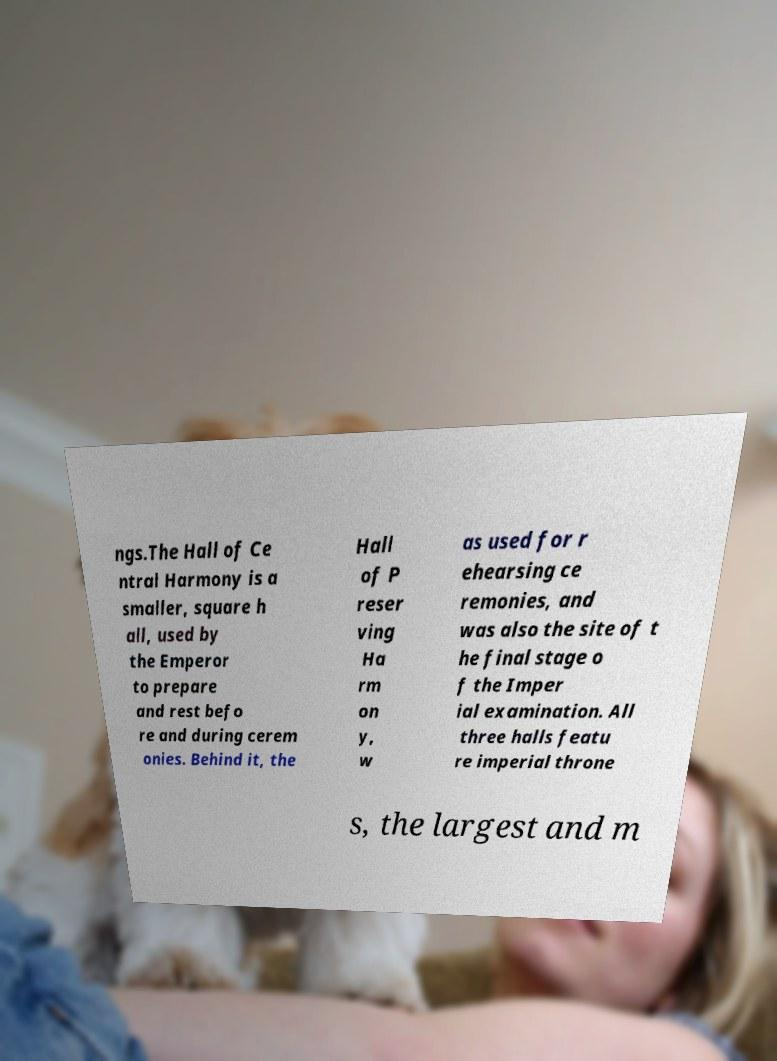Could you extract and type out the text from this image? ngs.The Hall of Ce ntral Harmony is a smaller, square h all, used by the Emperor to prepare and rest befo re and during cerem onies. Behind it, the Hall of P reser ving Ha rm on y, w as used for r ehearsing ce remonies, and was also the site of t he final stage o f the Imper ial examination. All three halls featu re imperial throne s, the largest and m 